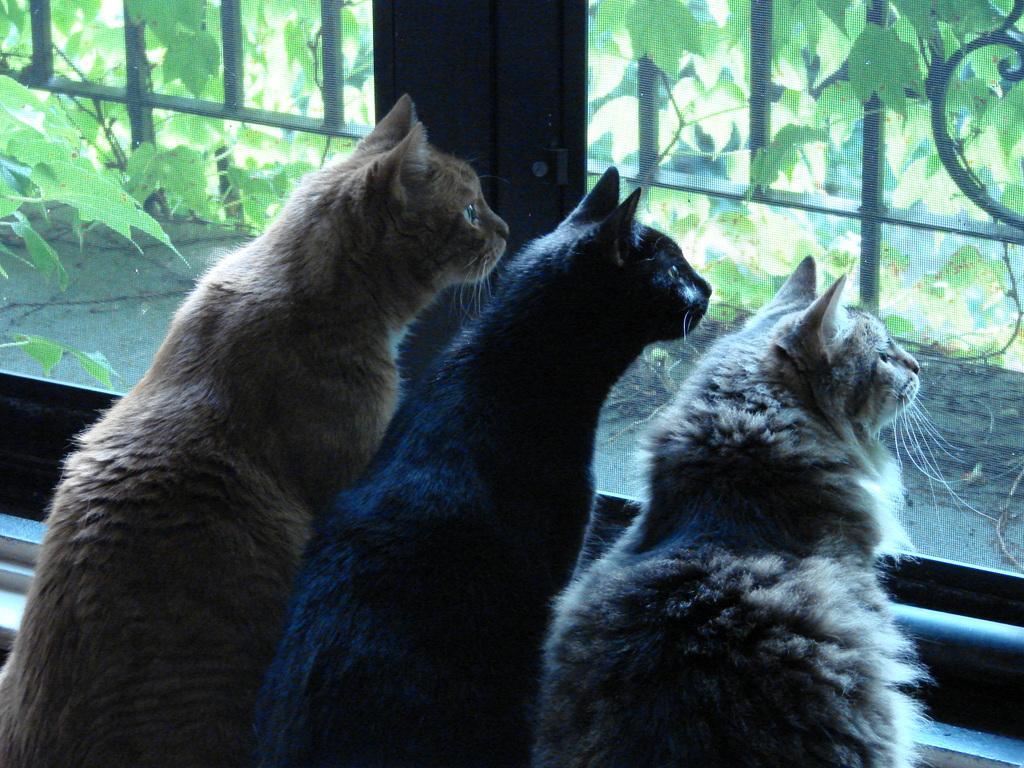How would you summarize this image in a sentence or two? In this picture I can see few cats one is brown and one is black and another one is light brown in color and I can see a glass window from the glass I can see a metal fence and few plants. 